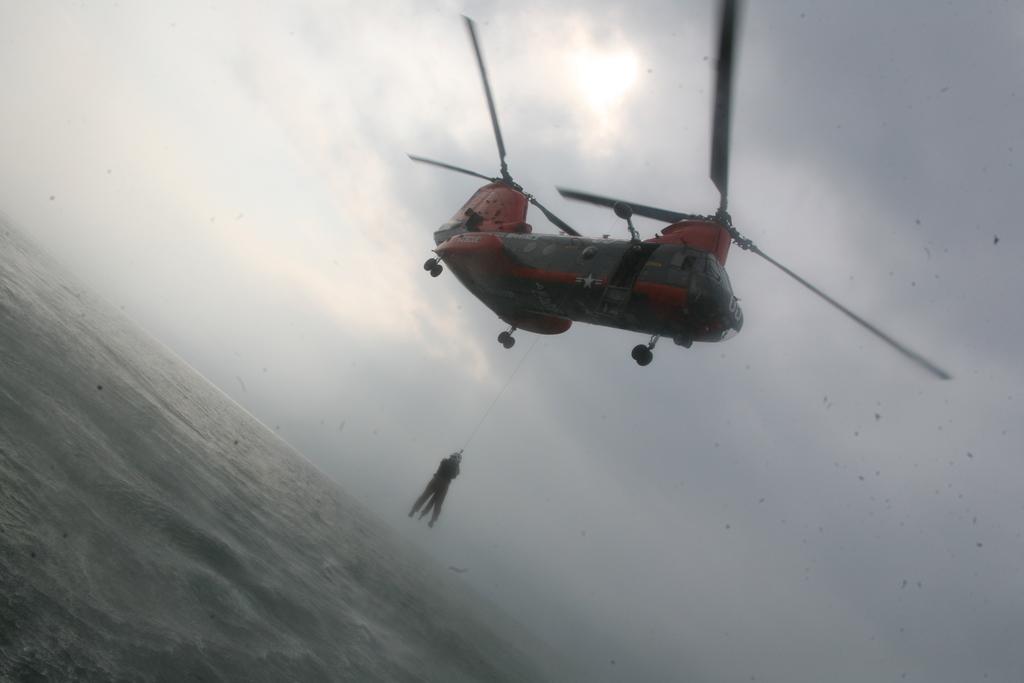How would you summarize this image in a sentence or two? In this image there is the sky towards the top of the image, there is an aircraft, there is a man hanging, he is holding an object, there is water towards the bottom of the image. 